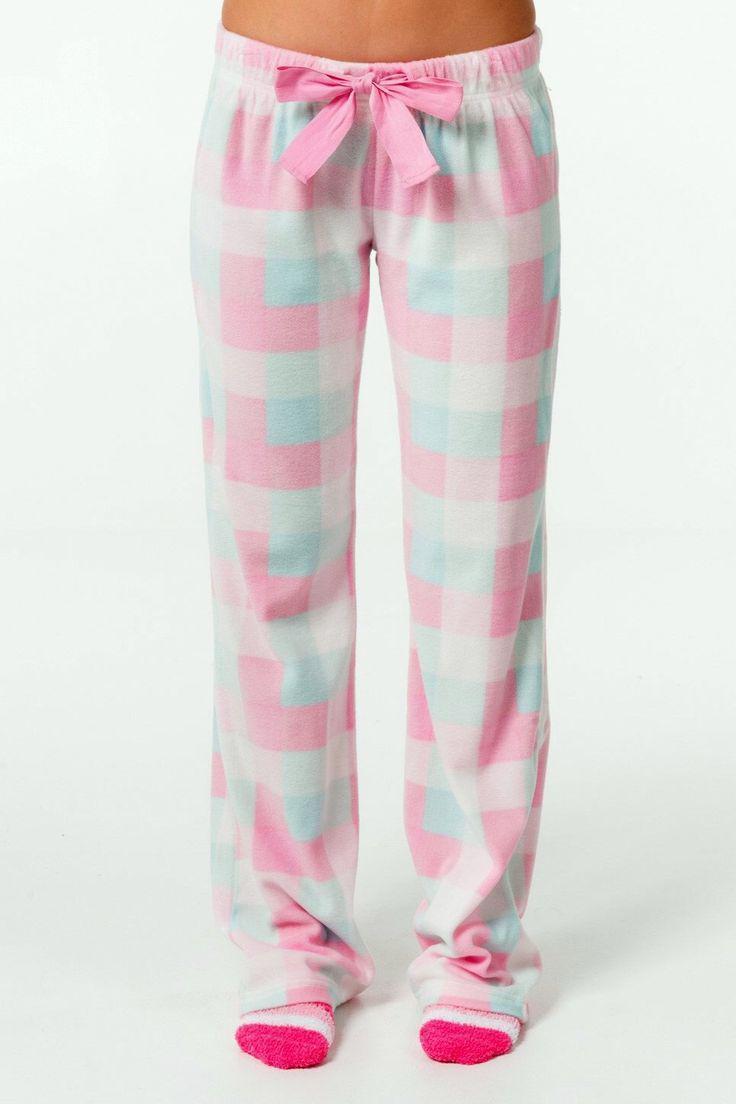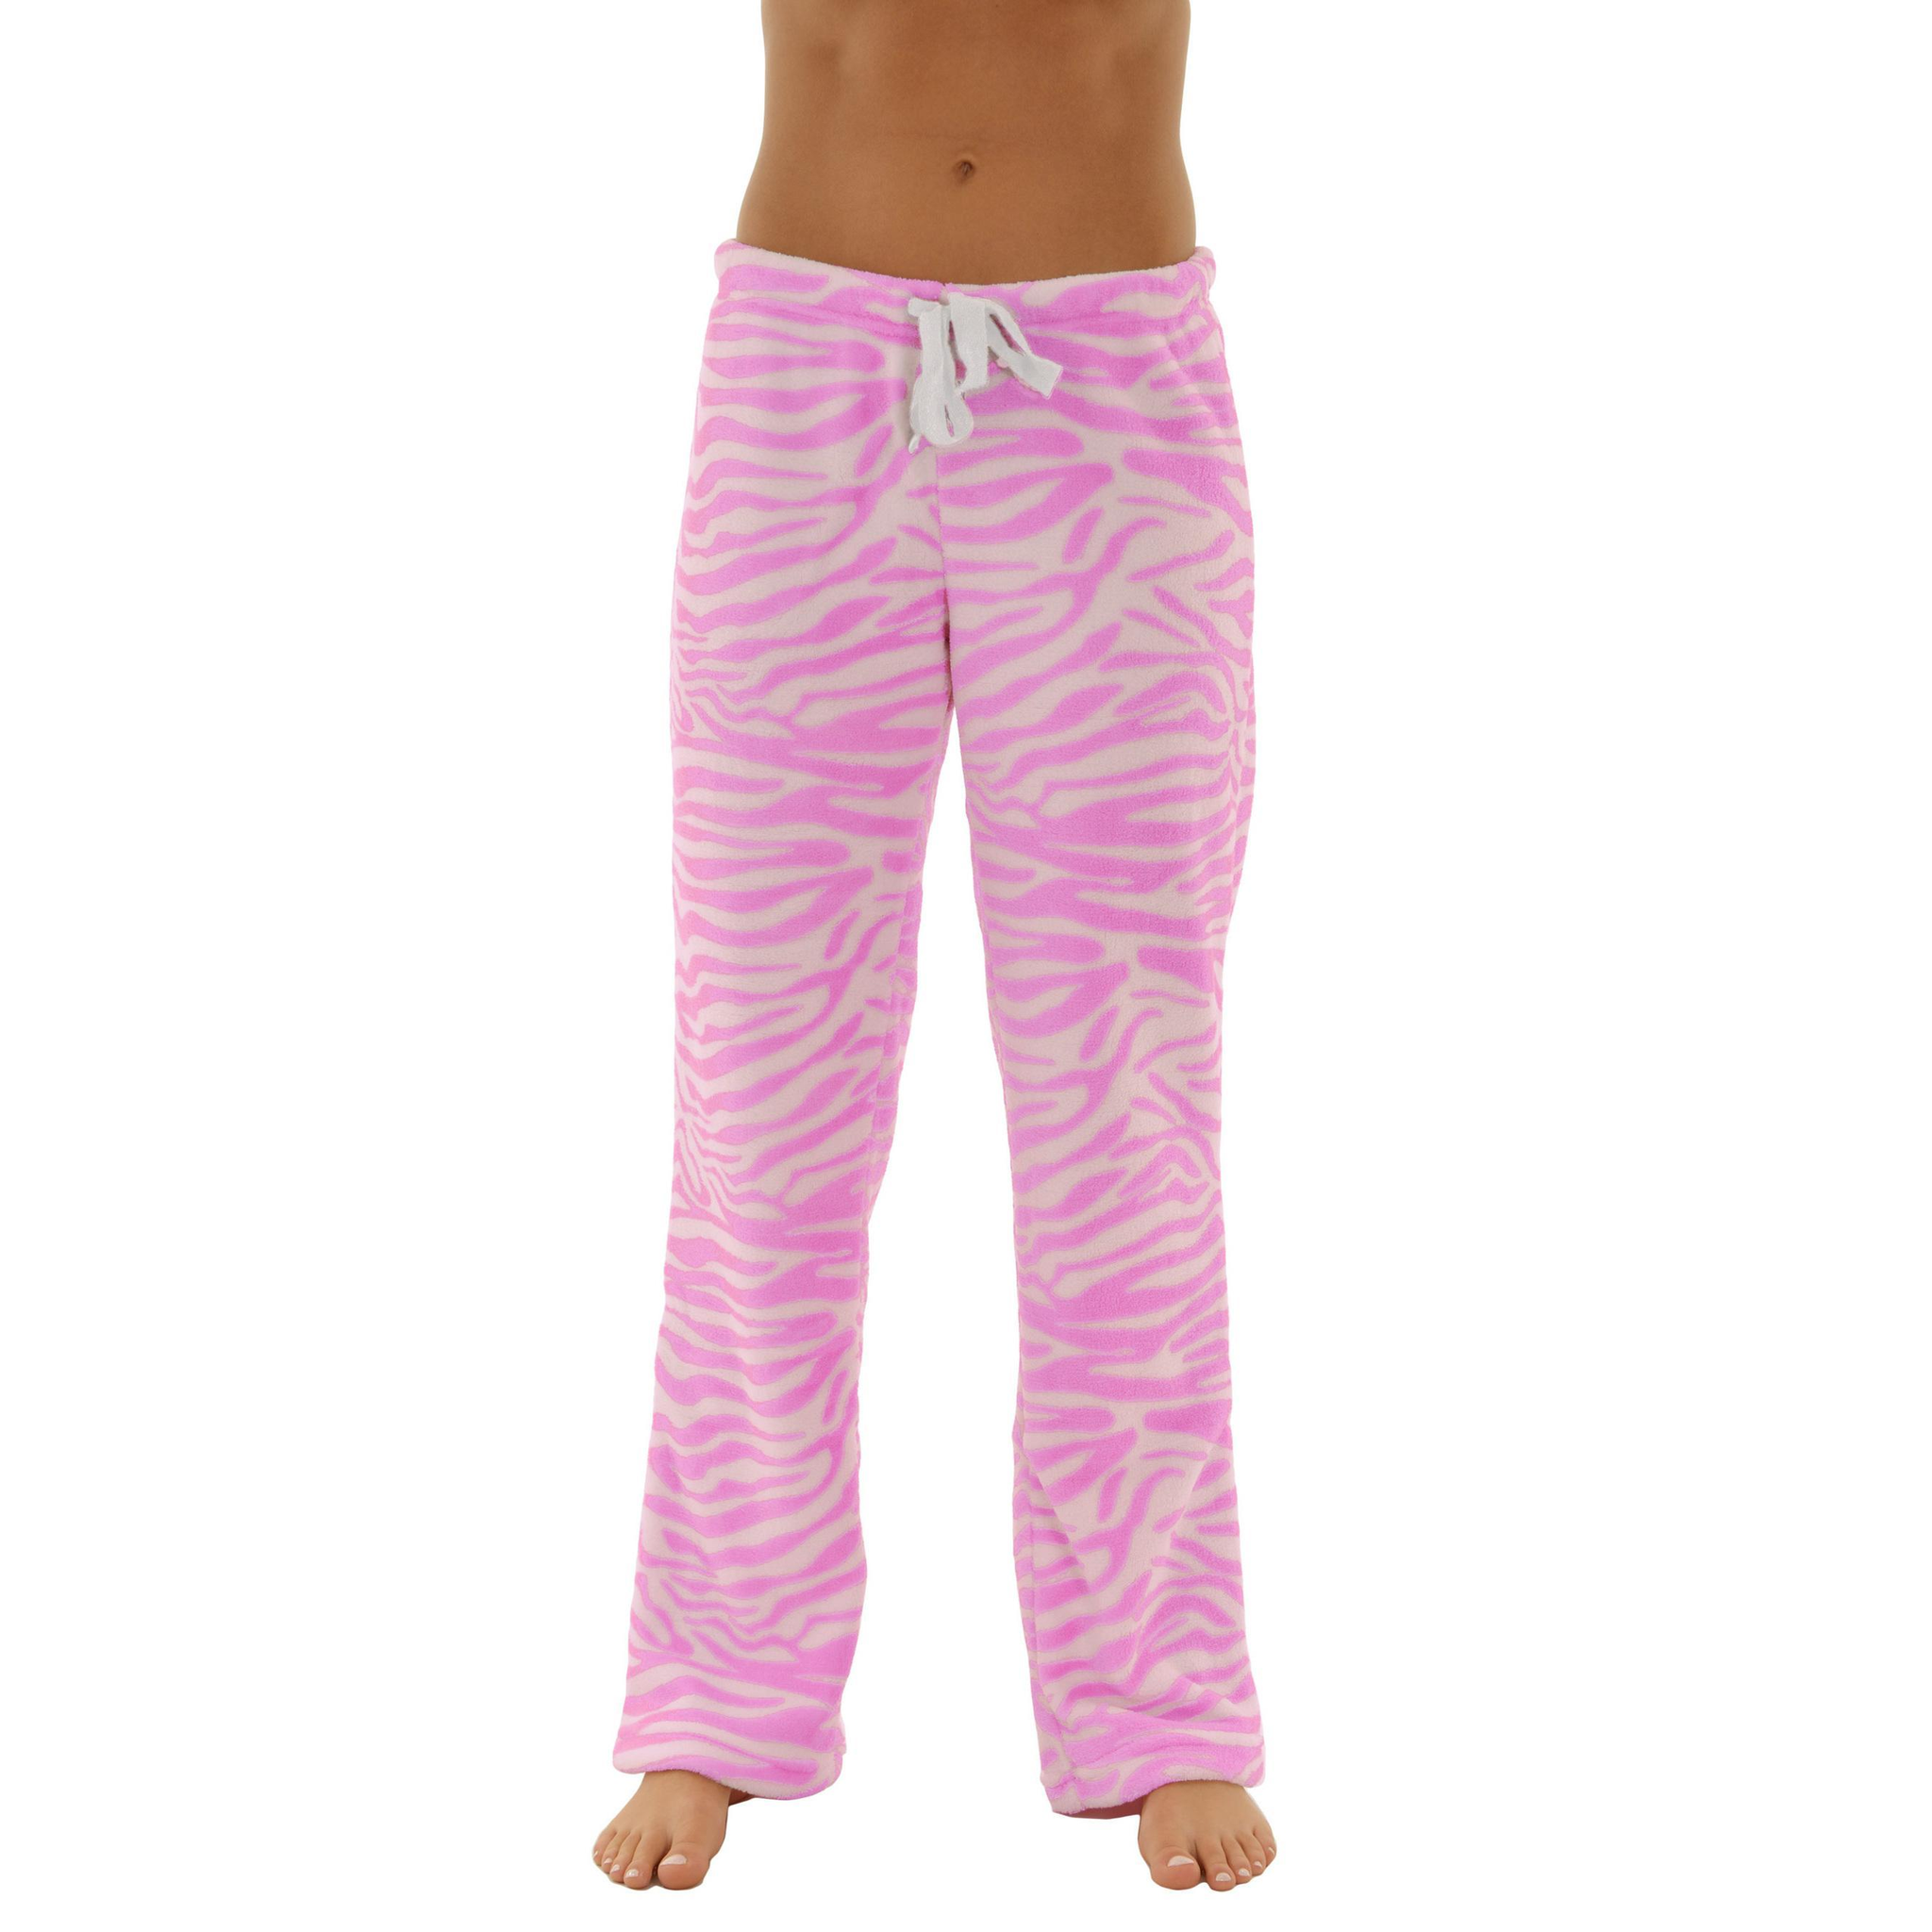The first image is the image on the left, the second image is the image on the right. For the images shown, is this caption "One image features pajama pants with a square pattern." true? Answer yes or no. Yes. 